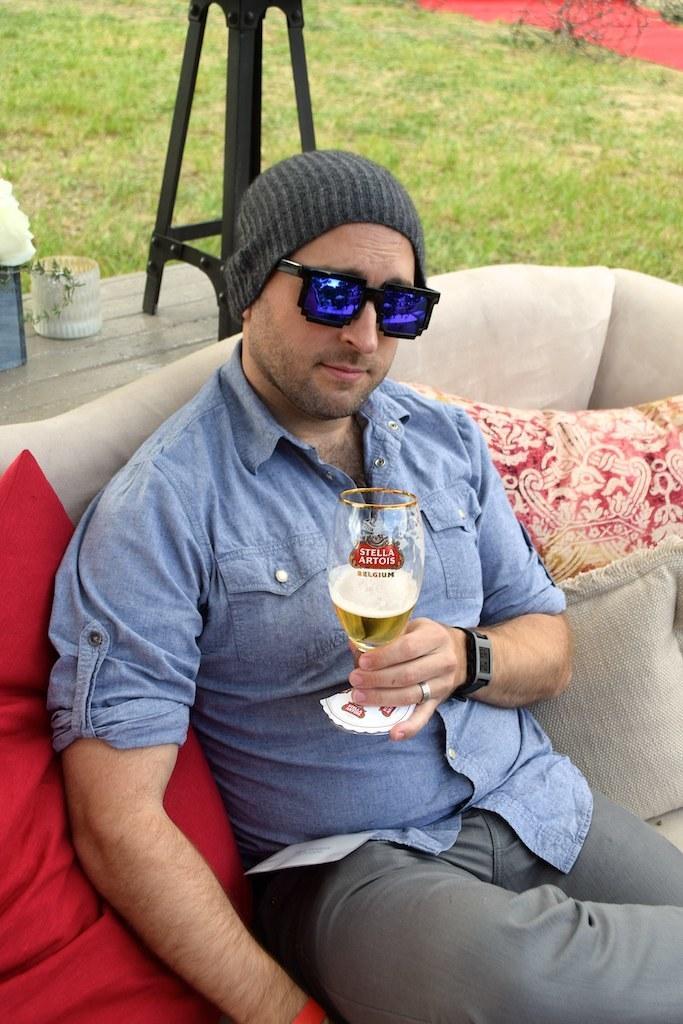In one or two sentences, can you explain what this image depicts? It is a picture taken outdoor when one person is sitting on the sofa and wearing blue shirt and pant and holding a beer glass in his hands and there are pillows on the sofa and behind him there is a bench with some plants on it and there is a grass behind him and he is wearing glasses and cap. 